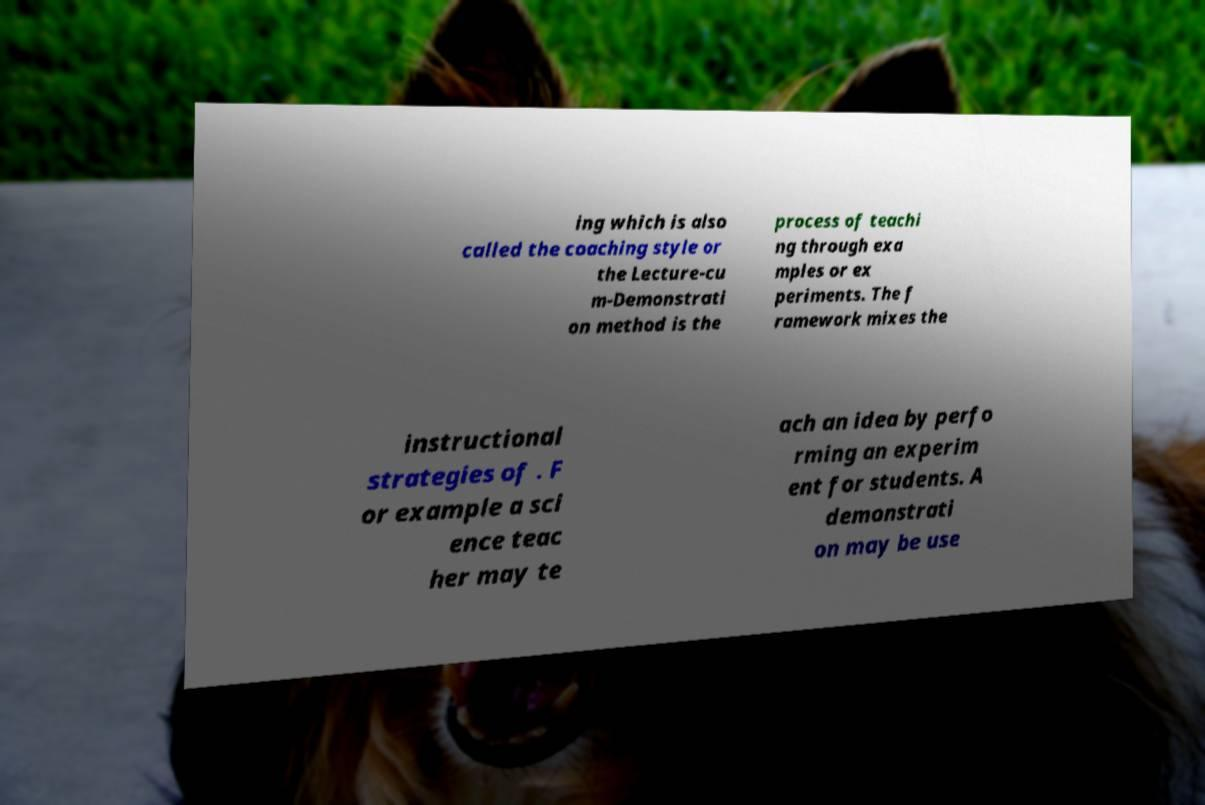Could you assist in decoding the text presented in this image and type it out clearly? ing which is also called the coaching style or the Lecture-cu m-Demonstrati on method is the process of teachi ng through exa mples or ex periments. The f ramework mixes the instructional strategies of . F or example a sci ence teac her may te ach an idea by perfo rming an experim ent for students. A demonstrati on may be use 